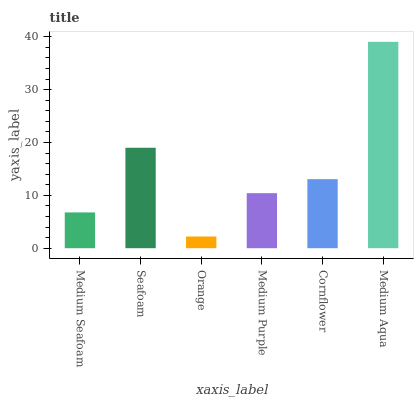Is Orange the minimum?
Answer yes or no. Yes. Is Medium Aqua the maximum?
Answer yes or no. Yes. Is Seafoam the minimum?
Answer yes or no. No. Is Seafoam the maximum?
Answer yes or no. No. Is Seafoam greater than Medium Seafoam?
Answer yes or no. Yes. Is Medium Seafoam less than Seafoam?
Answer yes or no. Yes. Is Medium Seafoam greater than Seafoam?
Answer yes or no. No. Is Seafoam less than Medium Seafoam?
Answer yes or no. No. Is Cornflower the high median?
Answer yes or no. Yes. Is Medium Purple the low median?
Answer yes or no. Yes. Is Seafoam the high median?
Answer yes or no. No. Is Seafoam the low median?
Answer yes or no. No. 